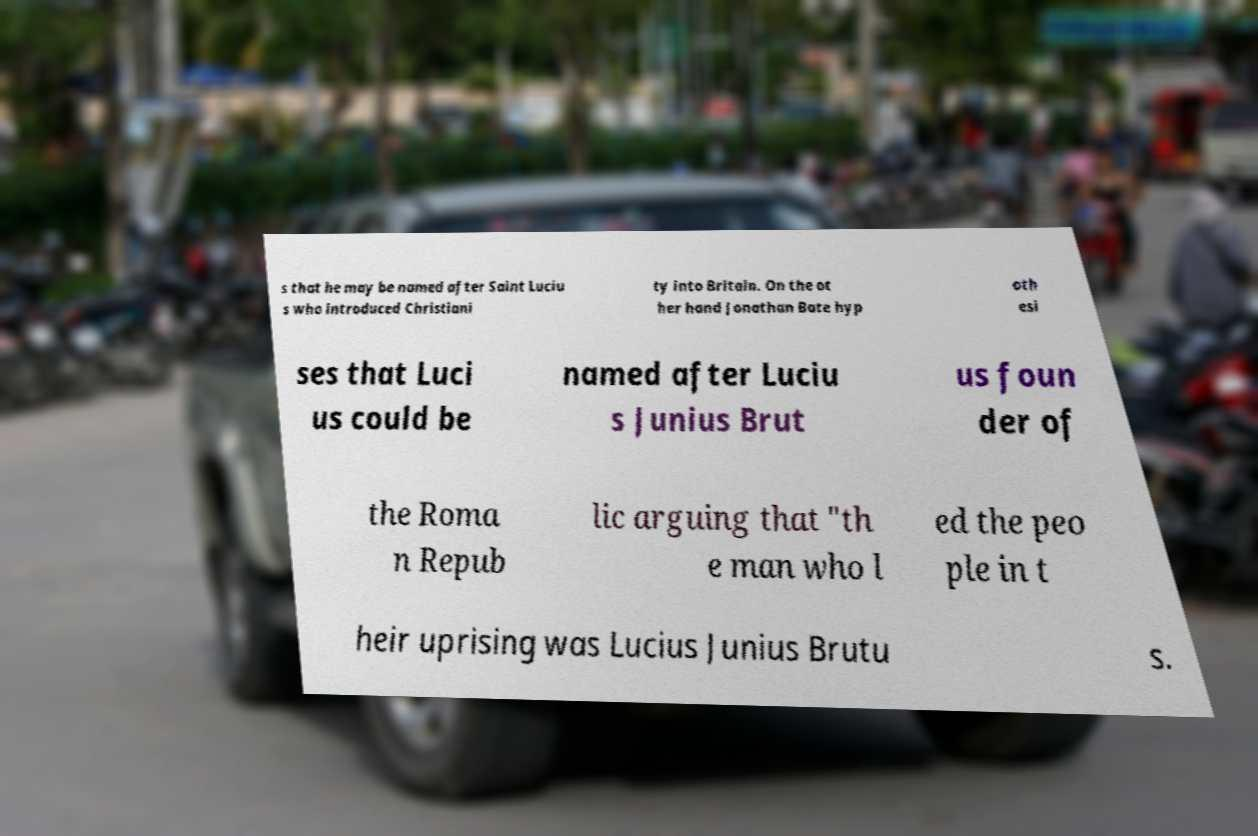Can you read and provide the text displayed in the image?This photo seems to have some interesting text. Can you extract and type it out for me? s that he may be named after Saint Luciu s who introduced Christiani ty into Britain. On the ot her hand Jonathan Bate hyp oth esi ses that Luci us could be named after Luciu s Junius Brut us foun der of the Roma n Repub lic arguing that "th e man who l ed the peo ple in t heir uprising was Lucius Junius Brutu s. 